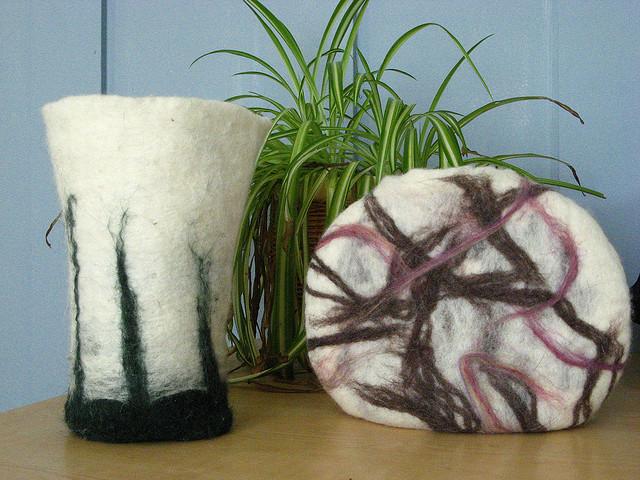What color is the plant?
Concise answer only. Green. What is in the vase?
Write a very short answer. Plant. What color is the wall behind the table?
Quick response, please. Blue. What are the two objects on the table?
Keep it brief. Plant and felt item. 